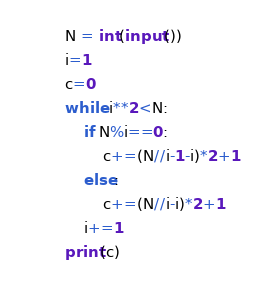<code> <loc_0><loc_0><loc_500><loc_500><_Python_>N = int(input())
i=1
c=0
while i**2<N:
    if N%i==0:
        c+=(N//i-1-i)*2+1
    else:
        c+=(N//i-i)*2+1
    i+=1
print(c)</code> 